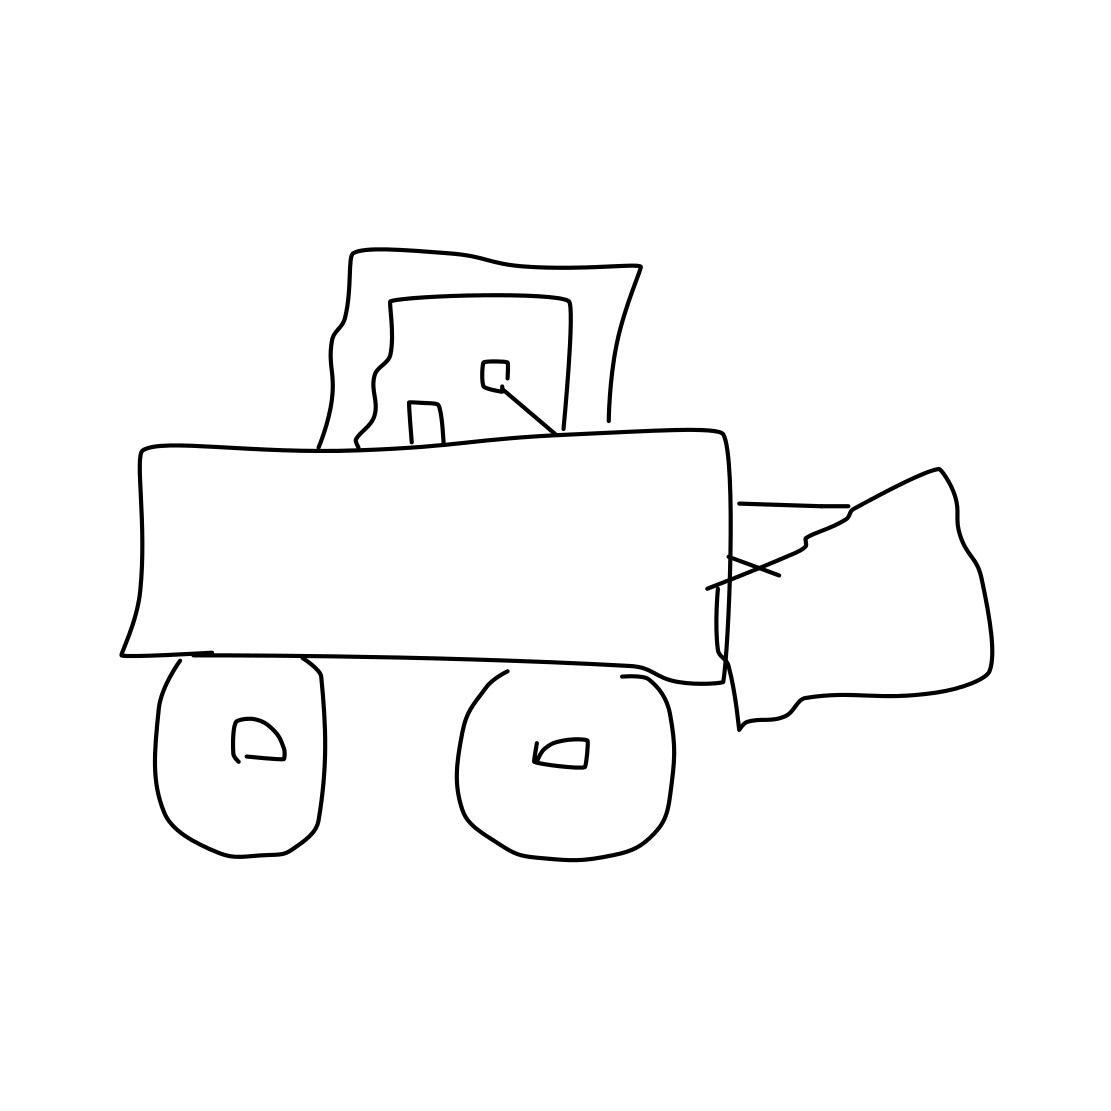What could a child learn from this image? A child looking at this image could learn about the basic shape and function of construction equipment like a bulldozer. The simplicity of the drawing is very accessible, allowing a child to easily identify the different parts like the blade and the wheels, while also sparking imagination about how such vehicles operate and their role in building and transforming landscapes. Could this drawing be improved in any way to make it more realistic or detailed? Absolutely. To enhance realism, detail can be added to various components like tread patterns on the wheels or tracks, showing the cabin's windows, door handles, and controls, and refining the blade with more accurate proportions and angles. Including a background context, such as a construction site, might also give the bulldozer a sense of placement and scale. 